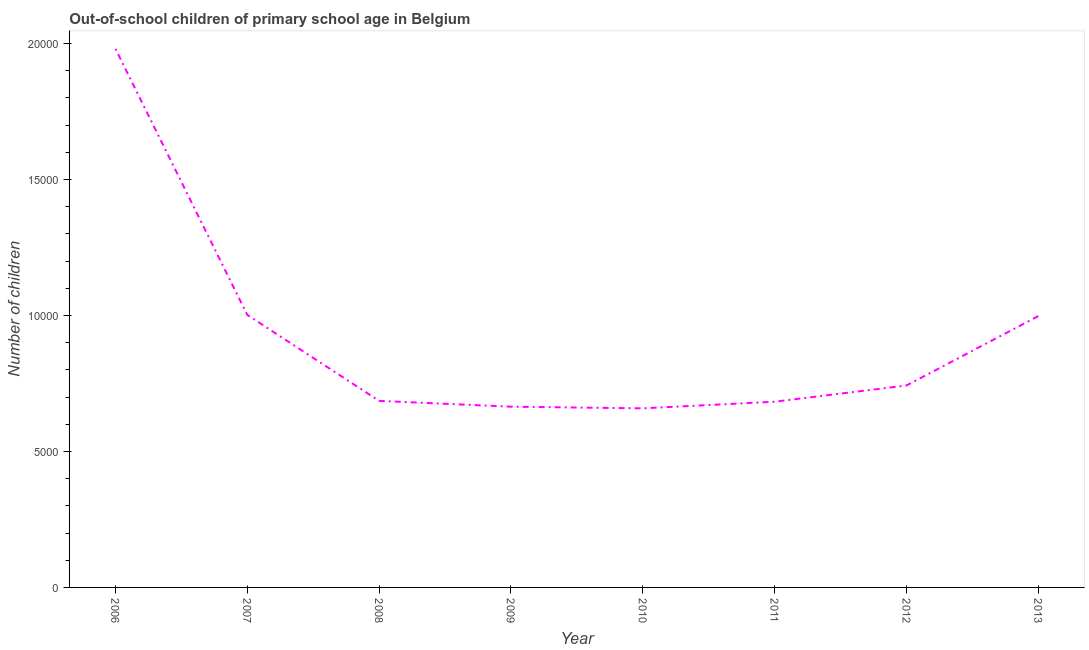What is the number of out-of-school children in 2010?
Keep it short and to the point. 6586. Across all years, what is the maximum number of out-of-school children?
Provide a succinct answer. 1.98e+04. Across all years, what is the minimum number of out-of-school children?
Your response must be concise. 6586. What is the sum of the number of out-of-school children?
Make the answer very short. 7.42e+04. What is the difference between the number of out-of-school children in 2006 and 2012?
Offer a very short reply. 1.24e+04. What is the average number of out-of-school children per year?
Ensure brevity in your answer.  9270.5. What is the median number of out-of-school children?
Your response must be concise. 7144. What is the ratio of the number of out-of-school children in 2006 to that in 2013?
Your response must be concise. 1.98. Is the number of out-of-school children in 2007 less than that in 2012?
Offer a terse response. No. Is the difference between the number of out-of-school children in 2009 and 2012 greater than the difference between any two years?
Your answer should be compact. No. What is the difference between the highest and the second highest number of out-of-school children?
Give a very brief answer. 9786. Is the sum of the number of out-of-school children in 2009 and 2012 greater than the maximum number of out-of-school children across all years?
Your answer should be very brief. No. What is the difference between the highest and the lowest number of out-of-school children?
Your response must be concise. 1.32e+04. In how many years, is the number of out-of-school children greater than the average number of out-of-school children taken over all years?
Give a very brief answer. 3. Does the number of out-of-school children monotonically increase over the years?
Give a very brief answer. No. How many years are there in the graph?
Ensure brevity in your answer.  8. Are the values on the major ticks of Y-axis written in scientific E-notation?
Your answer should be compact. No. What is the title of the graph?
Ensure brevity in your answer.  Out-of-school children of primary school age in Belgium. What is the label or title of the Y-axis?
Your answer should be very brief. Number of children. What is the Number of children in 2006?
Make the answer very short. 1.98e+04. What is the Number of children in 2007?
Your response must be concise. 1.00e+04. What is the Number of children of 2008?
Your answer should be very brief. 6861. What is the Number of children of 2009?
Offer a very short reply. 6647. What is the Number of children of 2010?
Your response must be concise. 6586. What is the Number of children in 2011?
Your answer should be very brief. 6830. What is the Number of children in 2012?
Your response must be concise. 7427. What is the Number of children in 2013?
Your answer should be compact. 9981. What is the difference between the Number of children in 2006 and 2007?
Ensure brevity in your answer.  9786. What is the difference between the Number of children in 2006 and 2008?
Your answer should be very brief. 1.29e+04. What is the difference between the Number of children in 2006 and 2009?
Give a very brief answer. 1.32e+04. What is the difference between the Number of children in 2006 and 2010?
Keep it short and to the point. 1.32e+04. What is the difference between the Number of children in 2006 and 2011?
Make the answer very short. 1.30e+04. What is the difference between the Number of children in 2006 and 2012?
Your answer should be very brief. 1.24e+04. What is the difference between the Number of children in 2006 and 2013?
Your response must be concise. 9828. What is the difference between the Number of children in 2007 and 2008?
Your response must be concise. 3162. What is the difference between the Number of children in 2007 and 2009?
Keep it short and to the point. 3376. What is the difference between the Number of children in 2007 and 2010?
Offer a very short reply. 3437. What is the difference between the Number of children in 2007 and 2011?
Provide a short and direct response. 3193. What is the difference between the Number of children in 2007 and 2012?
Keep it short and to the point. 2596. What is the difference between the Number of children in 2007 and 2013?
Your answer should be very brief. 42. What is the difference between the Number of children in 2008 and 2009?
Your answer should be very brief. 214. What is the difference between the Number of children in 2008 and 2010?
Your answer should be very brief. 275. What is the difference between the Number of children in 2008 and 2012?
Provide a succinct answer. -566. What is the difference between the Number of children in 2008 and 2013?
Make the answer very short. -3120. What is the difference between the Number of children in 2009 and 2011?
Make the answer very short. -183. What is the difference between the Number of children in 2009 and 2012?
Make the answer very short. -780. What is the difference between the Number of children in 2009 and 2013?
Make the answer very short. -3334. What is the difference between the Number of children in 2010 and 2011?
Provide a short and direct response. -244. What is the difference between the Number of children in 2010 and 2012?
Your response must be concise. -841. What is the difference between the Number of children in 2010 and 2013?
Your answer should be compact. -3395. What is the difference between the Number of children in 2011 and 2012?
Keep it short and to the point. -597. What is the difference between the Number of children in 2011 and 2013?
Your answer should be very brief. -3151. What is the difference between the Number of children in 2012 and 2013?
Offer a very short reply. -2554. What is the ratio of the Number of children in 2006 to that in 2007?
Make the answer very short. 1.98. What is the ratio of the Number of children in 2006 to that in 2008?
Offer a very short reply. 2.89. What is the ratio of the Number of children in 2006 to that in 2009?
Provide a short and direct response. 2.98. What is the ratio of the Number of children in 2006 to that in 2010?
Give a very brief answer. 3.01. What is the ratio of the Number of children in 2006 to that in 2011?
Keep it short and to the point. 2.9. What is the ratio of the Number of children in 2006 to that in 2012?
Keep it short and to the point. 2.67. What is the ratio of the Number of children in 2006 to that in 2013?
Provide a succinct answer. 1.99. What is the ratio of the Number of children in 2007 to that in 2008?
Provide a succinct answer. 1.46. What is the ratio of the Number of children in 2007 to that in 2009?
Ensure brevity in your answer.  1.51. What is the ratio of the Number of children in 2007 to that in 2010?
Your answer should be compact. 1.52. What is the ratio of the Number of children in 2007 to that in 2011?
Offer a very short reply. 1.47. What is the ratio of the Number of children in 2007 to that in 2012?
Provide a succinct answer. 1.35. What is the ratio of the Number of children in 2007 to that in 2013?
Provide a succinct answer. 1. What is the ratio of the Number of children in 2008 to that in 2009?
Offer a terse response. 1.03. What is the ratio of the Number of children in 2008 to that in 2010?
Make the answer very short. 1.04. What is the ratio of the Number of children in 2008 to that in 2012?
Ensure brevity in your answer.  0.92. What is the ratio of the Number of children in 2008 to that in 2013?
Make the answer very short. 0.69. What is the ratio of the Number of children in 2009 to that in 2010?
Make the answer very short. 1.01. What is the ratio of the Number of children in 2009 to that in 2011?
Your answer should be very brief. 0.97. What is the ratio of the Number of children in 2009 to that in 2012?
Provide a succinct answer. 0.9. What is the ratio of the Number of children in 2009 to that in 2013?
Give a very brief answer. 0.67. What is the ratio of the Number of children in 2010 to that in 2011?
Your answer should be compact. 0.96. What is the ratio of the Number of children in 2010 to that in 2012?
Your response must be concise. 0.89. What is the ratio of the Number of children in 2010 to that in 2013?
Provide a succinct answer. 0.66. What is the ratio of the Number of children in 2011 to that in 2012?
Your answer should be compact. 0.92. What is the ratio of the Number of children in 2011 to that in 2013?
Offer a very short reply. 0.68. What is the ratio of the Number of children in 2012 to that in 2013?
Your answer should be very brief. 0.74. 